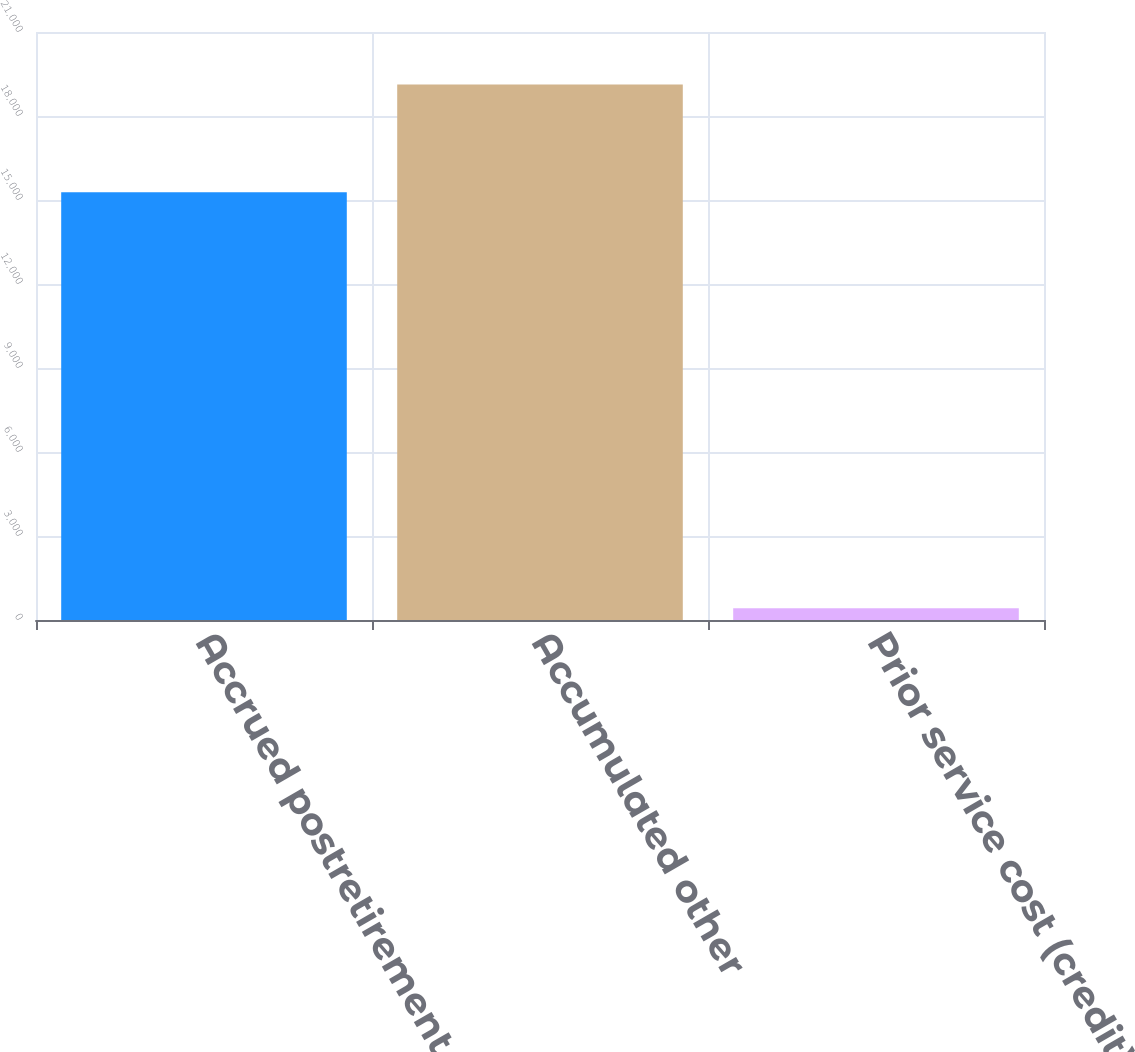Convert chart. <chart><loc_0><loc_0><loc_500><loc_500><bar_chart><fcel>Accrued postretirement benefit<fcel>Accumulated other<fcel>Prior service cost (credit)<nl><fcel>15278<fcel>19121<fcel>418<nl></chart> 